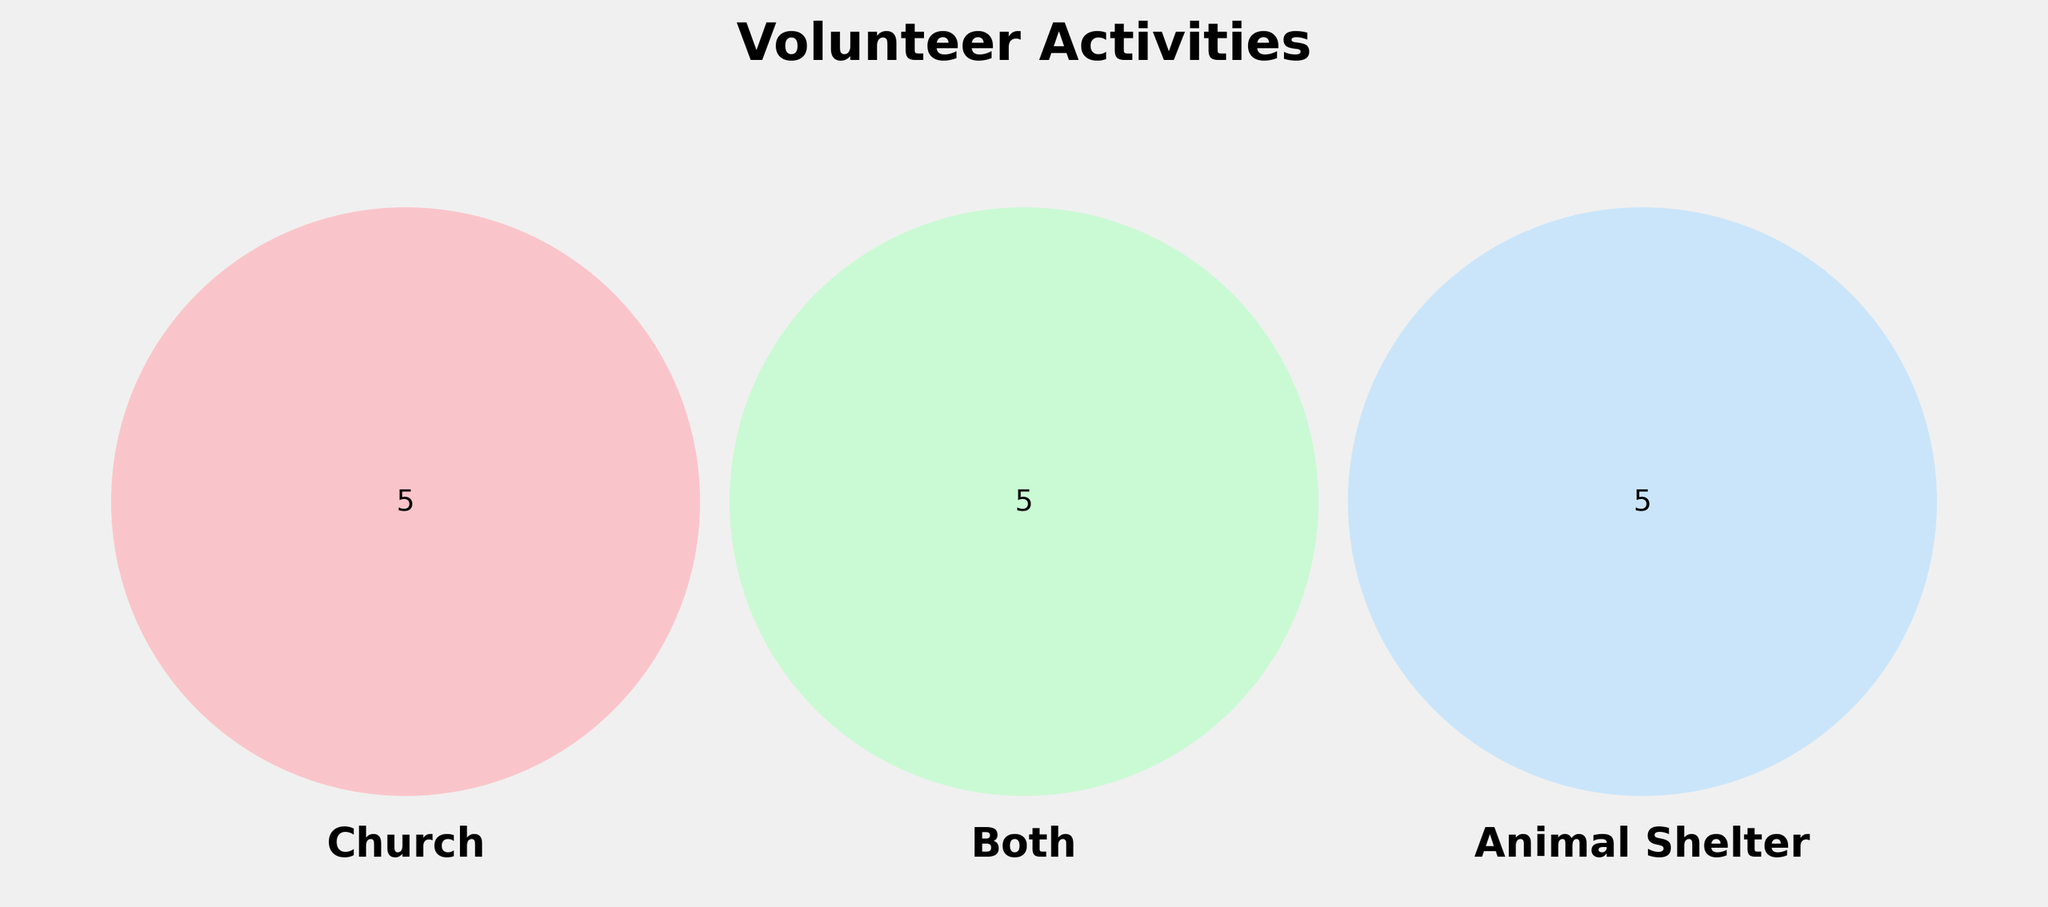What are the volunteer activities exclusive to the church? Look at the circle labeled "Church", which excludes overlaps with "Both" and "Animal Shelter". These are the activities within the "Church" circle only.
Answer: Sunday School teaching, Choir practice, Food bank assistance, Prayer groups, Vacation Bible School What are the volunteer activities that overlap between church and animal shelter activities? In the Venn Diagram, find the central intersecting area shared by all three circles.
Answer: Fundraising events Which activities are exclusively found in animal shelters? Look at the circle labeled "Animal Shelter" without any overlaps with other circles. These are the activities not shared with other categories.
Answer: Dog walking, Cat socialization, Shelter cleaning, Adoption counseling, Grooming assistance What color represents the activities that are common to churches and animal shelters but not exclusive to one? Observe the middle section where all three labeled areas overlap in the Venn Diagram.
Answer: Greenish (overlap area of all sections) How many activities are exclusive to shared efforts (both) but not specific to only one? Look at the area labeled "Both" without overlapping with "Church" or "Animal Shelter". It should be an independent area of overlap between two sets.
Answer: 3 (Pet blessing ceremonies, Fundraising events, Community outreach programs) What unique activities are found in both church and animal shelters? Identify the intersection areas of "Church" and "Animal Shelter" excluding the central area which represents all three. These are activities that overlap between church and animal shelters but not in both.
Answer: None (All activities that overlap between church and animal shelters overlap with all three areas) Compare the number of unique activities in churches vs. animal shelters. Which has more unique activities? Compare the count of activities exclusive to the "Church" circle and the "Animal Shelter" circle by tallying each category's items.
Answer: Animal Shelter What volunteer activity is found in all three areas? Find the central section that intersects all three labeled areas on the Venn Diagram.
Answer: Fundraising events How many total activities are catalogued in the figure? Sum the unique activities within the "Church", "Both", and "Animal Shelter" sections. Count each unique activity once.
Answer: 15 